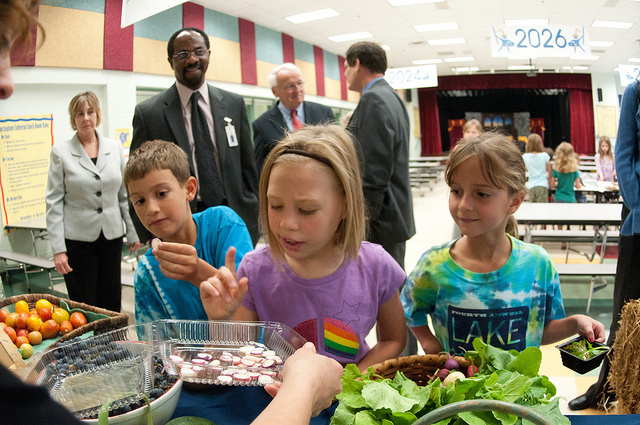Identify and read out the text in this image. 2026 LAKE 